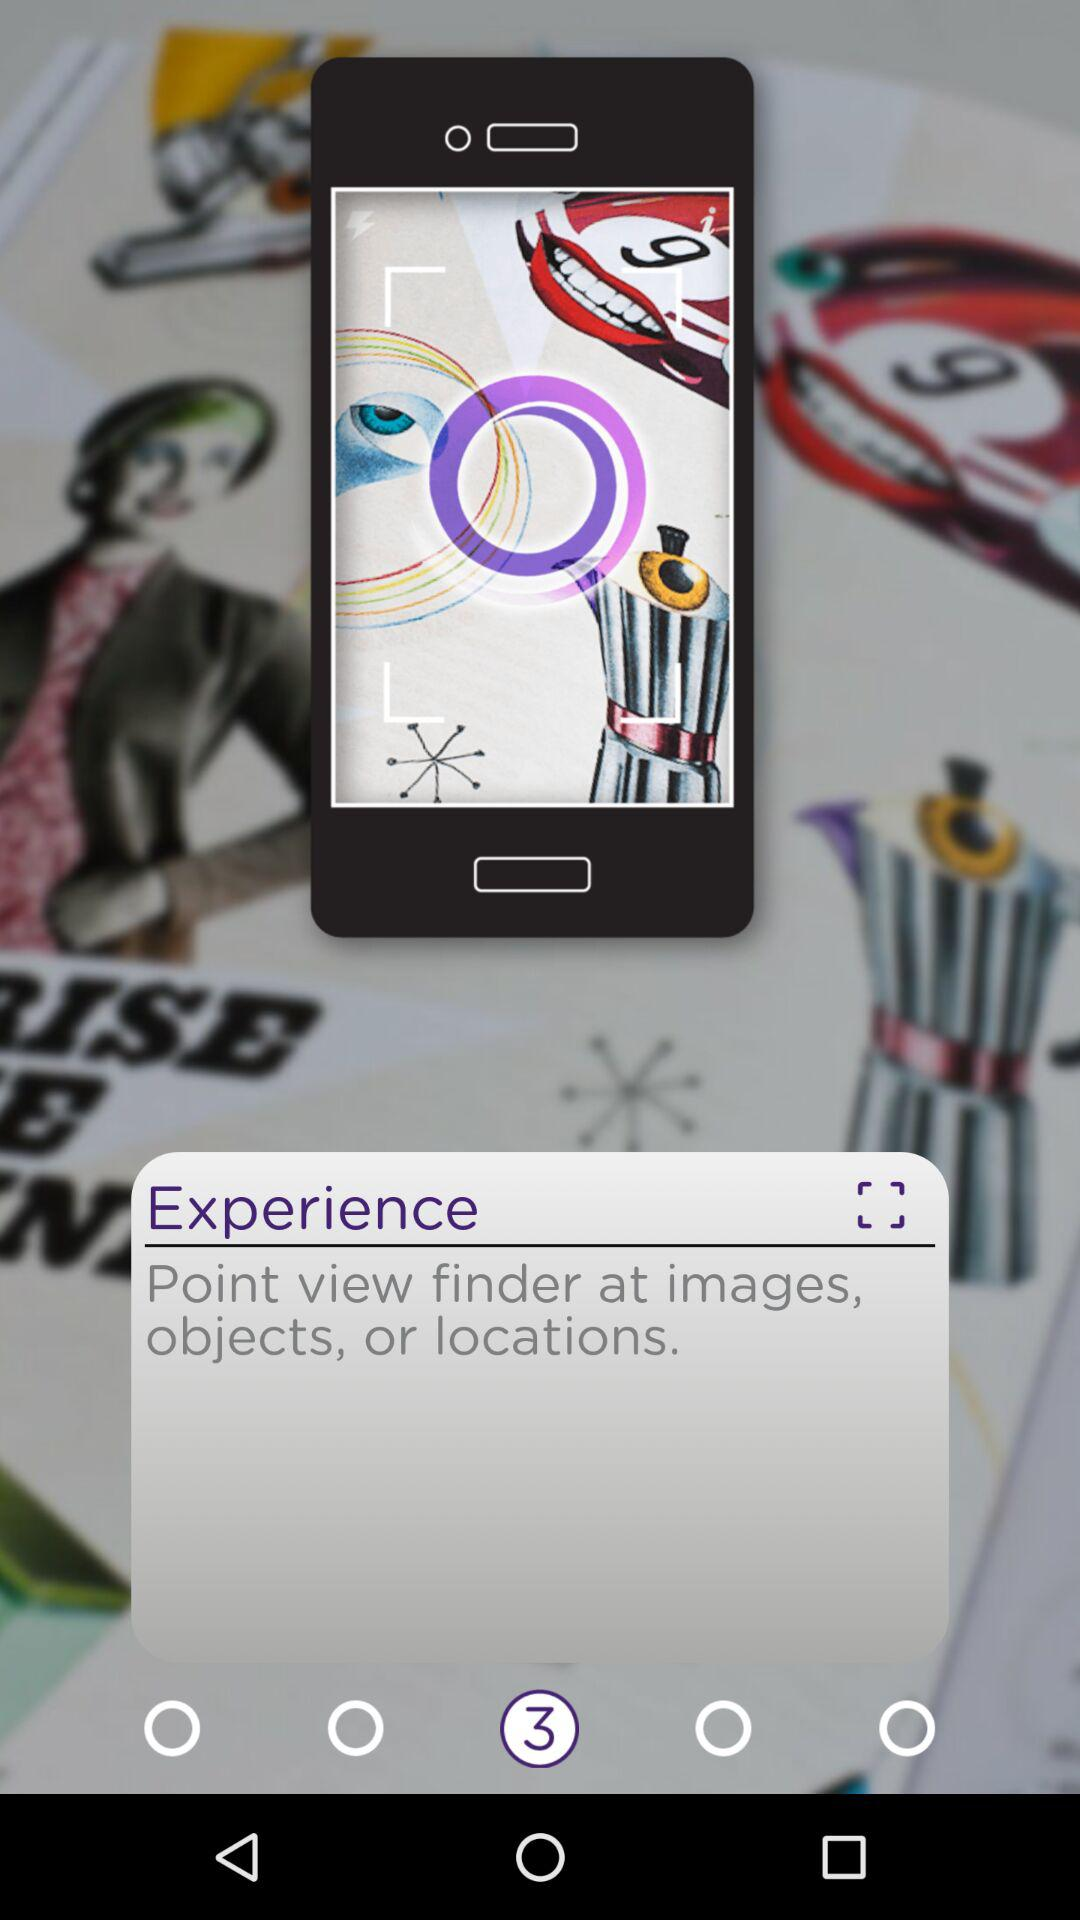What is the description given in the experience option? The description given is "Point view finder at images, objects, or locations". 